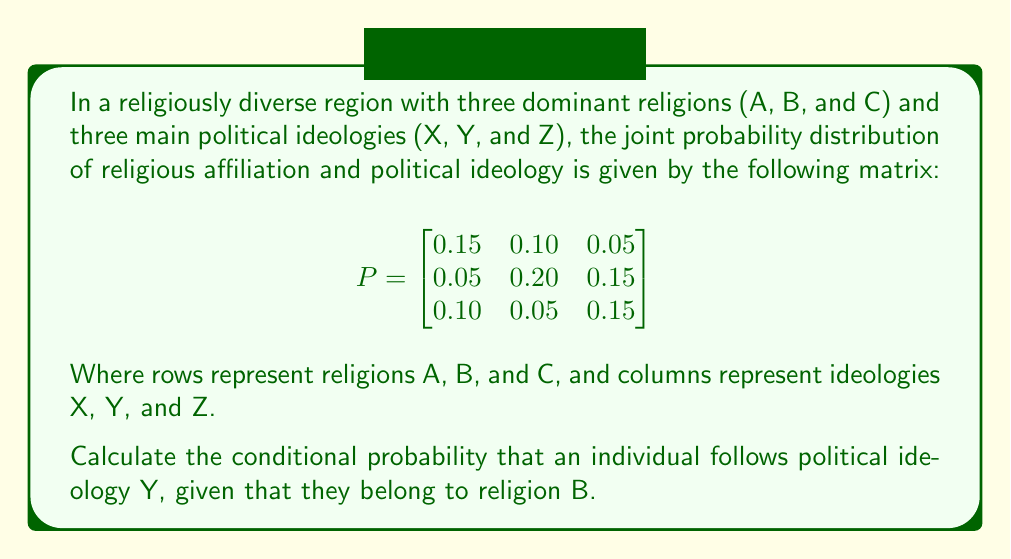Could you help me with this problem? To solve this problem, we need to use the formula for conditional probability:

$$P(Y|B) = \frac{P(Y \cap B)}{P(B)}$$

Step 1: Identify $P(Y \cap B)$ from the matrix.
$P(Y \cap B) = 0.20$ (second row, second column)

Step 2: Calculate $P(B)$ by summing the probabilities in the second row.
$P(B) = 0.05 + 0.20 + 0.15 = 0.40$

Step 3: Apply the conditional probability formula.
$$P(Y|B) = \frac{0.20}{0.40} = 0.50$$

Therefore, the conditional probability that an individual follows political ideology Y, given that they belong to religion B, is 0.50 or 50%.
Answer: 0.50 